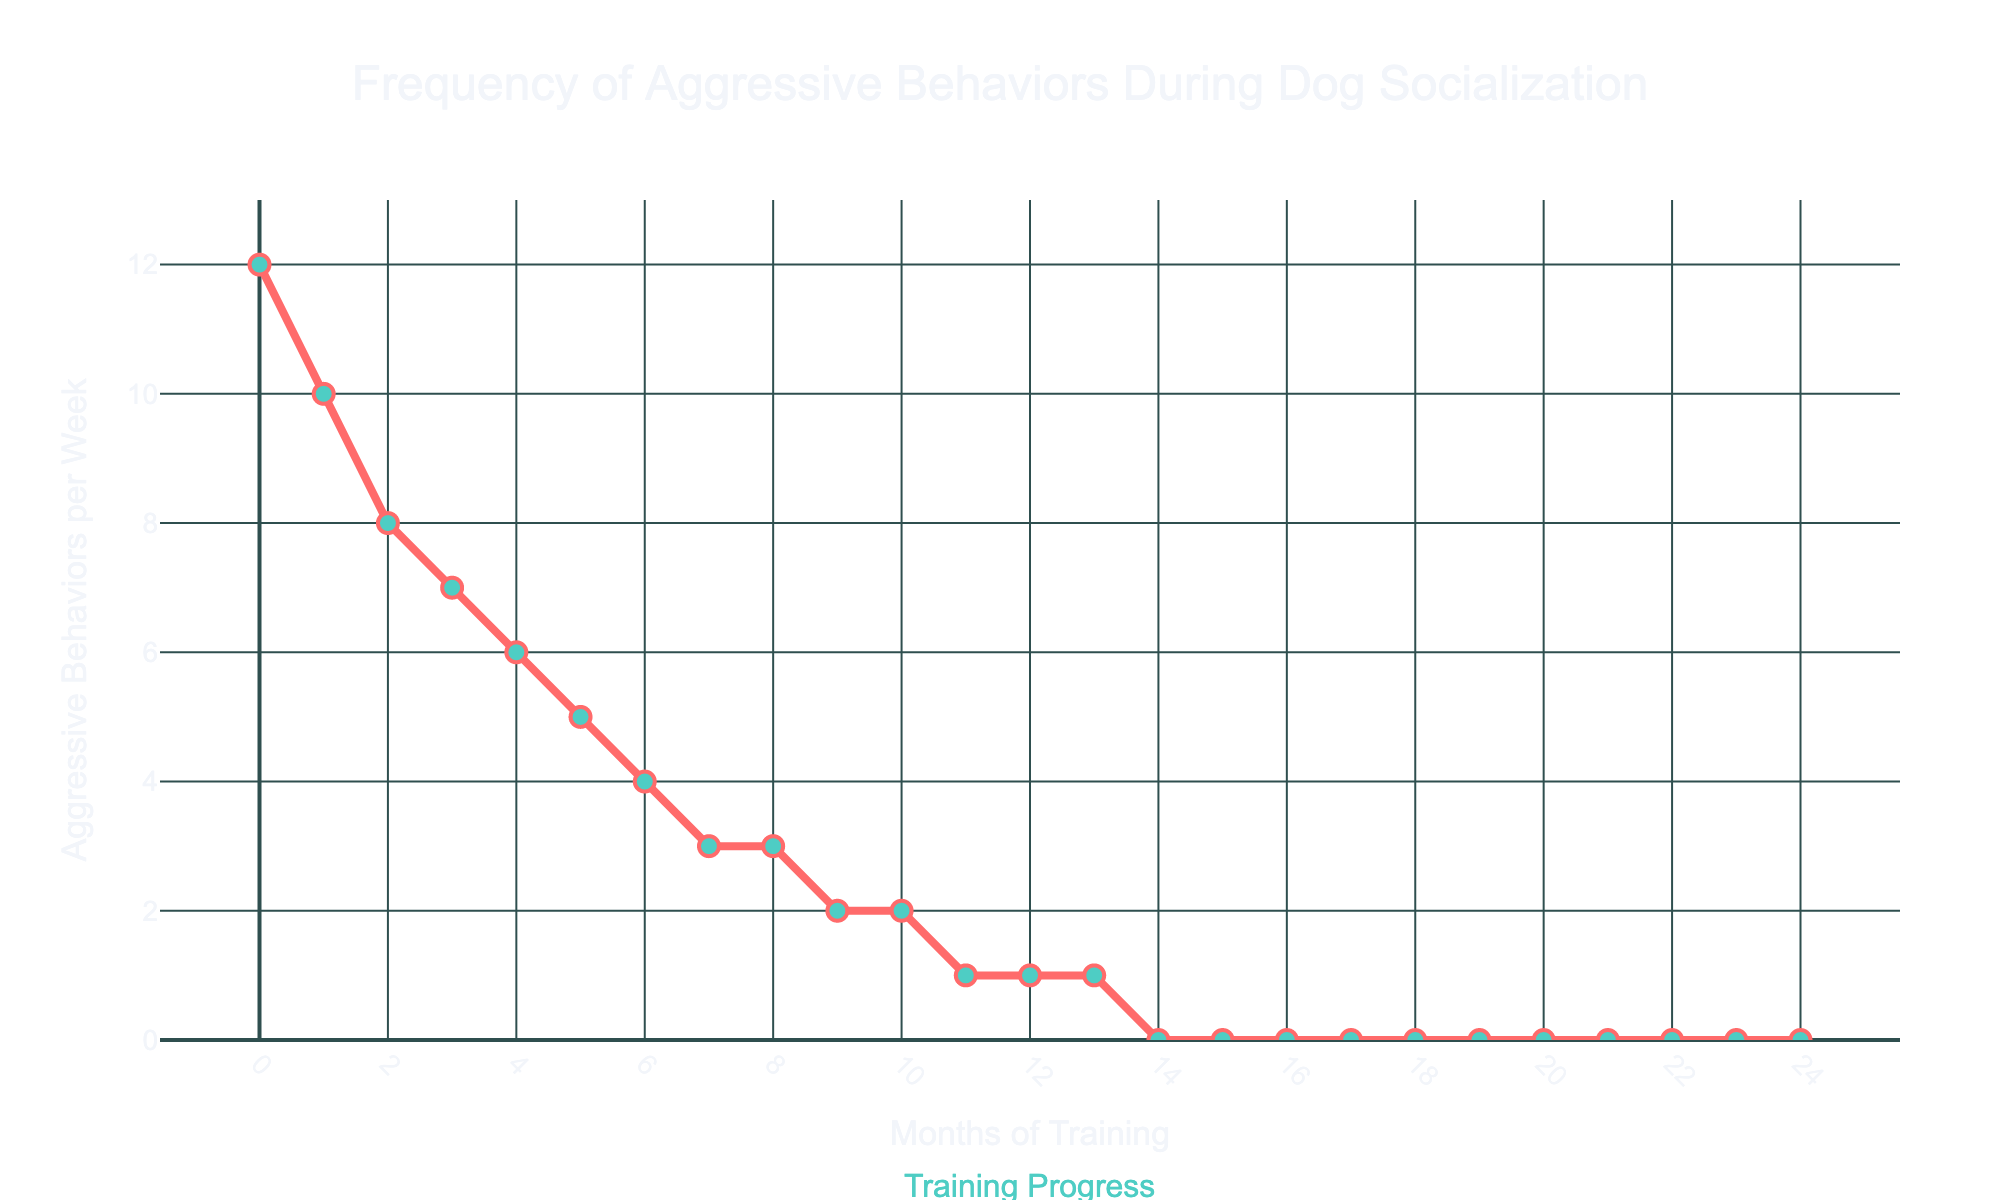what is the trend in aggressive behaviors over the training period? The figure shows a consistently decreasing trend in the aggressive behaviors per week across the 6-month training period. At the start (month 0), aggressive behaviors are at their highest. Over time, they decline steadily to zero behaviors from month 14 onwards.
Answer: Decreasing trend how many months did it take for aggressive behaviors to drop to near zero? By observing the line chart, aggressive behaviors drop to near zero (1 behavior per week) by month 11. From month 11 onwards, aggressive behaviors are at or near zero.
Answer: 11 months What’s the total decrease in aggressive behaviors per week from the start to the lowest point? The initial value at month 0 is 12 aggressive behaviors per week. The lowest point is after 24 months with 0 aggressive behaviors per week. The total decrease is 12 - 0 = 12.
Answer: 12 Which months have the same number of aggressive behaviors per week? From the figure, months 8 and 9 both have 3 aggressive behaviors per week, months 10 and 11 both have 2 aggressive behaviors per week, and months 12 to 13 all have 1 aggressive behavior per week. Finally, months 14 to 24 all have 0 aggressive behaviors per week.
Answer: Months 8 and 9, Months 10 and 11, Months 12 to 13, Months 14 to 24 What is the average number of aggressive behaviors per week over the first half of the training period (first 12 months)? Adding all aggressive behaviors per week from month 0 to month 11 gives: 12 + 10 + 8 + 7 + 6 + 5 + 4 + 3 + 3 + 2 + 2 + 1 = 63. The average is then 63 divided by 12 months.
Answer: 5.25 what visual elements are used to distinguish months in the line chart? The chart uses markers at each month denoted by circles, colors to distinguish the line and markers, and x-axis ticks labeled every 2 months.
Answer: Circles and x-axis ticks how frequently are the x-axis ticks labeled? Observing the figure, the x-axis ticks are labeled every 2 months.
Answer: Every 2 months compare the aggressive behaviors at the start of the training to the end of the training At the start (month 0), there are 12 aggressive behaviors per week. At the end (month 24), there are 0 aggressive behaviors per week. This shows a decrease from 12 to 0.
Answer: 12 and 0 